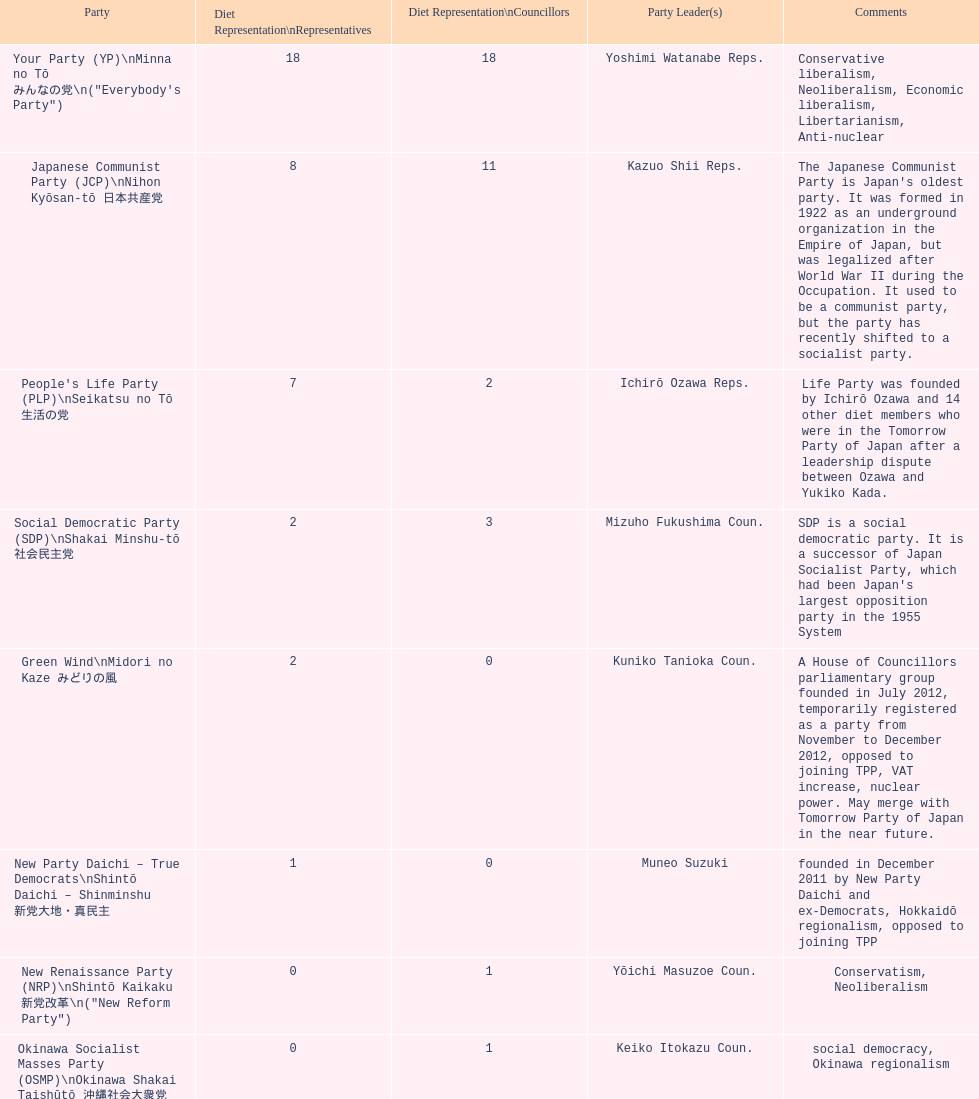What party has the most representatives in the diet representation? Your Party. Would you mind parsing the complete table? {'header': ['Party', 'Diet Representation\\nRepresentatives', 'Diet Representation\\nCouncillors', 'Party Leader(s)', 'Comments'], 'rows': [['Your Party (YP)\\nMinna no Tō みんなの党\\n("Everybody\'s Party")', '18', '18', 'Yoshimi Watanabe Reps.', 'Conservative liberalism, Neoliberalism, Economic liberalism, Libertarianism, Anti-nuclear'], ['Japanese Communist Party (JCP)\\nNihon Kyōsan-tō 日本共産党', '8', '11', 'Kazuo Shii Reps.', "The Japanese Communist Party is Japan's oldest party. It was formed in 1922 as an underground organization in the Empire of Japan, but was legalized after World War II during the Occupation. It used to be a communist party, but the party has recently shifted to a socialist party."], ["People's Life Party (PLP)\\nSeikatsu no Tō 生活の党", '7', '2', 'Ichirō Ozawa Reps.', 'Life Party was founded by Ichirō Ozawa and 14 other diet members who were in the Tomorrow Party of Japan after a leadership dispute between Ozawa and Yukiko Kada.'], ['Social Democratic Party (SDP)\\nShakai Minshu-tō 社会民主党', '2', '3', 'Mizuho Fukushima Coun.', "SDP is a social democratic party. It is a successor of Japan Socialist Party, which had been Japan's largest opposition party in the 1955 System"], ['Green Wind\\nMidori no Kaze みどりの風', '2', '0', 'Kuniko Tanioka Coun.', 'A House of Councillors parliamentary group founded in July 2012, temporarily registered as a party from November to December 2012, opposed to joining TPP, VAT increase, nuclear power. May merge with Tomorrow Party of Japan in the near future.'], ['New Party Daichi – True Democrats\\nShintō Daichi – Shinminshu 新党大地・真民主', '1', '0', 'Muneo Suzuki', 'founded in December 2011 by New Party Daichi and ex-Democrats, Hokkaidō regionalism, opposed to joining TPP'], ['New Renaissance Party (NRP)\\nShintō Kaikaku 新党改革\\n("New Reform Party")', '0', '1', 'Yōichi Masuzoe Coun.', 'Conservatism, Neoliberalism'], ['Okinawa Socialist Masses Party (OSMP)\\nOkinawa Shakai Taishūtō 沖縄社会大衆党', '0', '1', 'Keiko Itokazu Coun.', 'social democracy, Okinawa regionalism']]} 